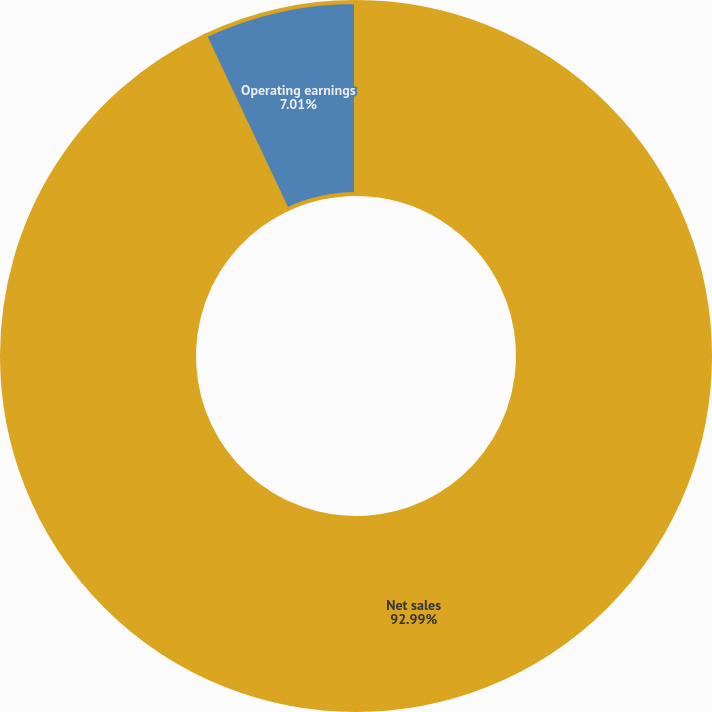Convert chart to OTSL. <chart><loc_0><loc_0><loc_500><loc_500><pie_chart><fcel>Net sales<fcel>Operating earnings<nl><fcel>92.99%<fcel>7.01%<nl></chart> 